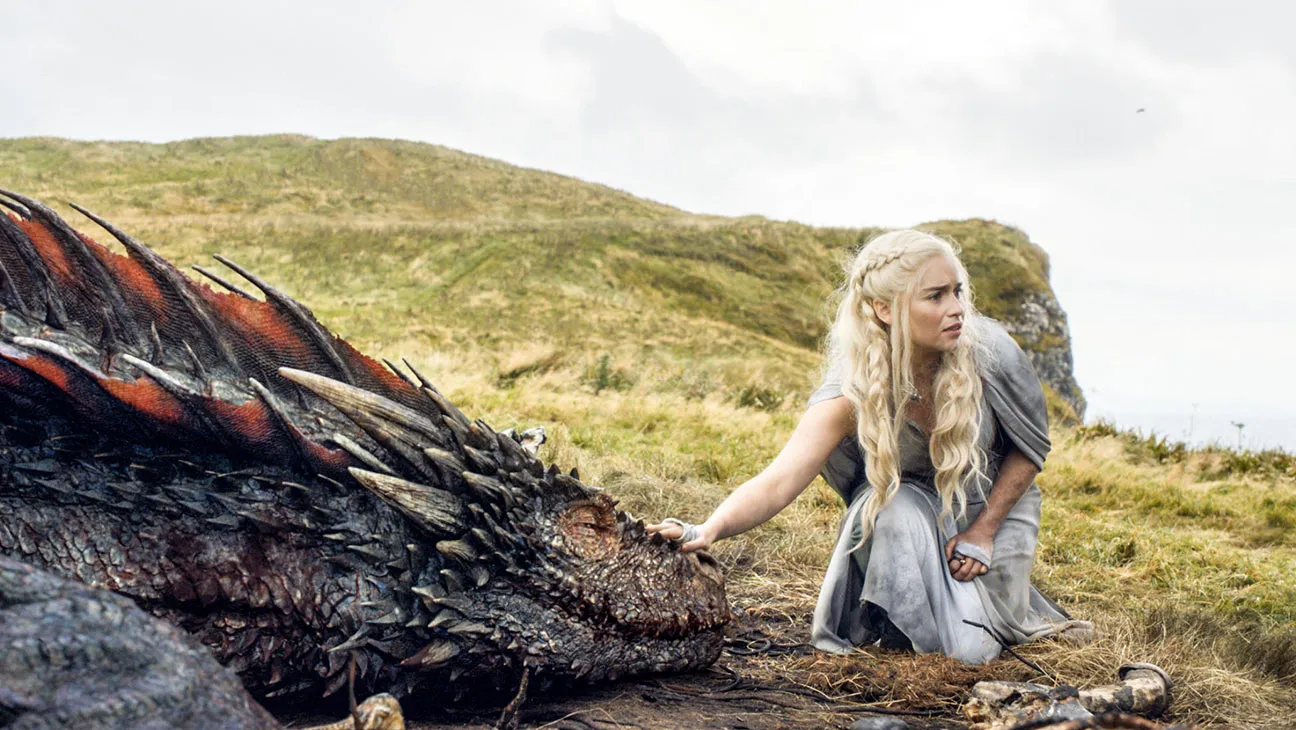Describe the following image. In this image, Emilia Clarke, known for her role as Daenerys Targaryen in the television show Game of Thrones, is seen in a moment of quiet intimacy with a large dragon. The dragon, a majestic creature with scales of red and black, is situated to her side on a grassy hill. Emilia, dressed in a simple gray dress that contrasts with the vibrant colors of the dragon, kneels on the grass next to the dragon. Her long blonde hair flows down her back, catching the light. With an expression of concern etched on her face, she reaches out, her hand just about to touch the dragon's head. The backdrop of the scene is a cloudy sky, adding a sense of drama to the image. 